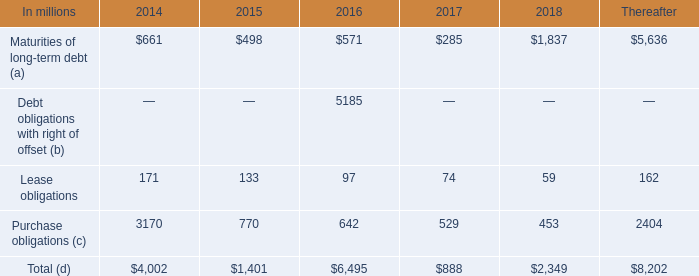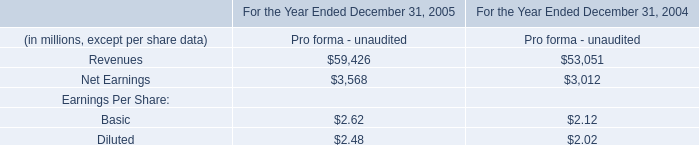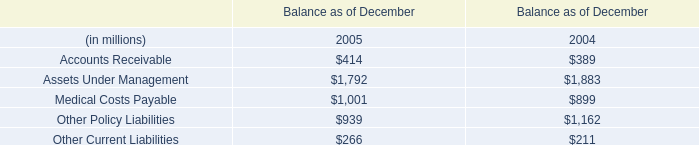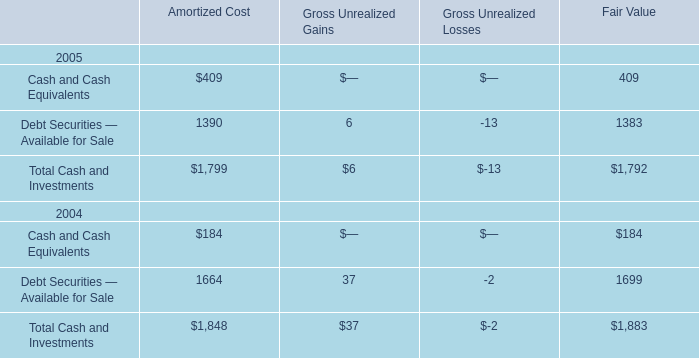What is the sum of Balance as of December in the range of 1000 and 2000 in 2005? (in million) 
Computations: (1792 + 1001)
Answer: 2793.0. 